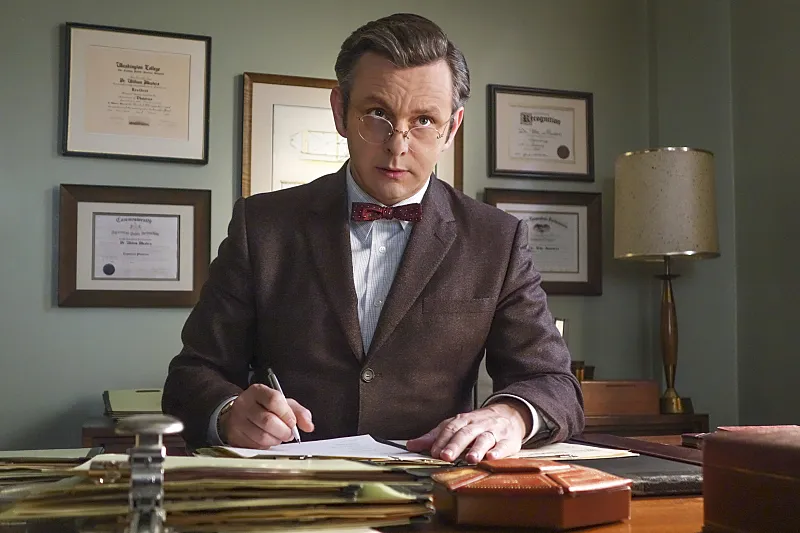Can you explain the significance of the certificates seen in the background? The certificates on the wall are not just decorative; they are indicative of the character's professional achievements and reputation. Each certificate likely represents a milestone or recognition in his medical career, reinforcing his credibility and expertise in his field. These details subtly underscore the character's dedication to his profession and his high standing in the academic and medical community, which are central themes of his role in the series. 